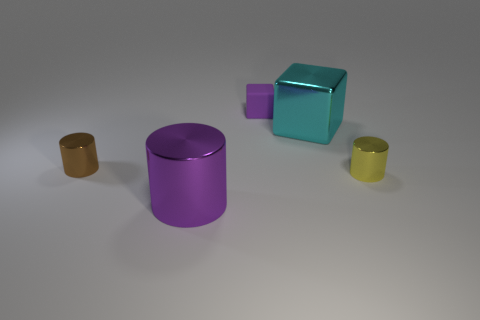Is there any other thing that has the same material as the tiny block?
Give a very brief answer. No. There is a metallic cylinder that is the same color as the small matte cube; what size is it?
Offer a very short reply. Large. How big is the shiny thing in front of the small cylinder on the right side of the small brown metallic object?
Make the answer very short. Large. Are there any other things that have the same shape as the brown metal object?
Offer a terse response. Yes. Does the metallic cylinder that is right of the matte block have the same size as the purple object behind the yellow shiny cylinder?
Offer a terse response. Yes. Are there fewer shiny blocks that are in front of the tiny yellow shiny cylinder than small yellow cylinders that are in front of the brown cylinder?
Offer a very short reply. Yes. There is a cylinder that is the same color as the rubber thing; what is it made of?
Provide a succinct answer. Metal. What color is the block to the right of the purple matte cube?
Provide a short and direct response. Cyan. Is the color of the rubber object the same as the large cylinder?
Your answer should be very brief. Yes. There is a purple object in front of the large object that is to the right of the purple metallic cylinder; how many objects are on the right side of it?
Your answer should be compact. 3. 